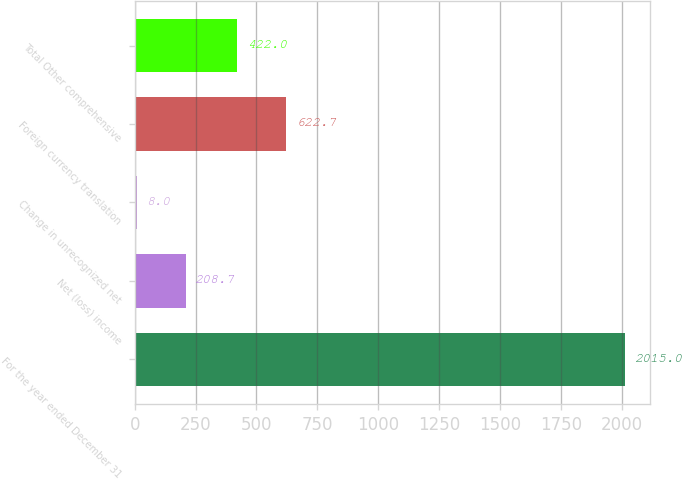Convert chart. <chart><loc_0><loc_0><loc_500><loc_500><bar_chart><fcel>For the year ended December 31<fcel>Net (loss) income<fcel>Change in unrecognized net<fcel>Foreign currency translation<fcel>Total Other comprehensive<nl><fcel>2015<fcel>208.7<fcel>8<fcel>622.7<fcel>422<nl></chart> 